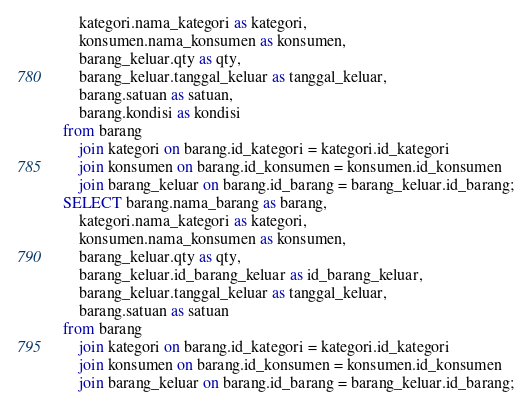Convert code to text. <code><loc_0><loc_0><loc_500><loc_500><_SQL_>    kategori.nama_kategori as kategori,
    konsumen.nama_konsumen as konsumen,
    barang_keluar.qty as qty,
    barang_keluar.tanggal_keluar as tanggal_keluar,
    barang.satuan as satuan,
    barang.kondisi as kondisi
from barang
    join kategori on barang.id_kategori = kategori.id_kategori
    join konsumen on barang.id_konsumen = konsumen.id_konsumen
    join barang_keluar on barang.id_barang = barang_keluar.id_barang;
SELECT barang.nama_barang as barang,
    kategori.nama_kategori as kategori,
    konsumen.nama_konsumen as konsumen,
    barang_keluar.qty as qty,
    barang_keluar.id_barang_keluar as id_barang_keluar,
    barang_keluar.tanggal_keluar as tanggal_keluar,
    barang.satuan as satuan
from barang
    join kategori on barang.id_kategori = kategori.id_kategori
    join konsumen on barang.id_konsumen = konsumen.id_konsumen
    join barang_keluar on barang.id_barang = barang_keluar.id_barang;</code> 